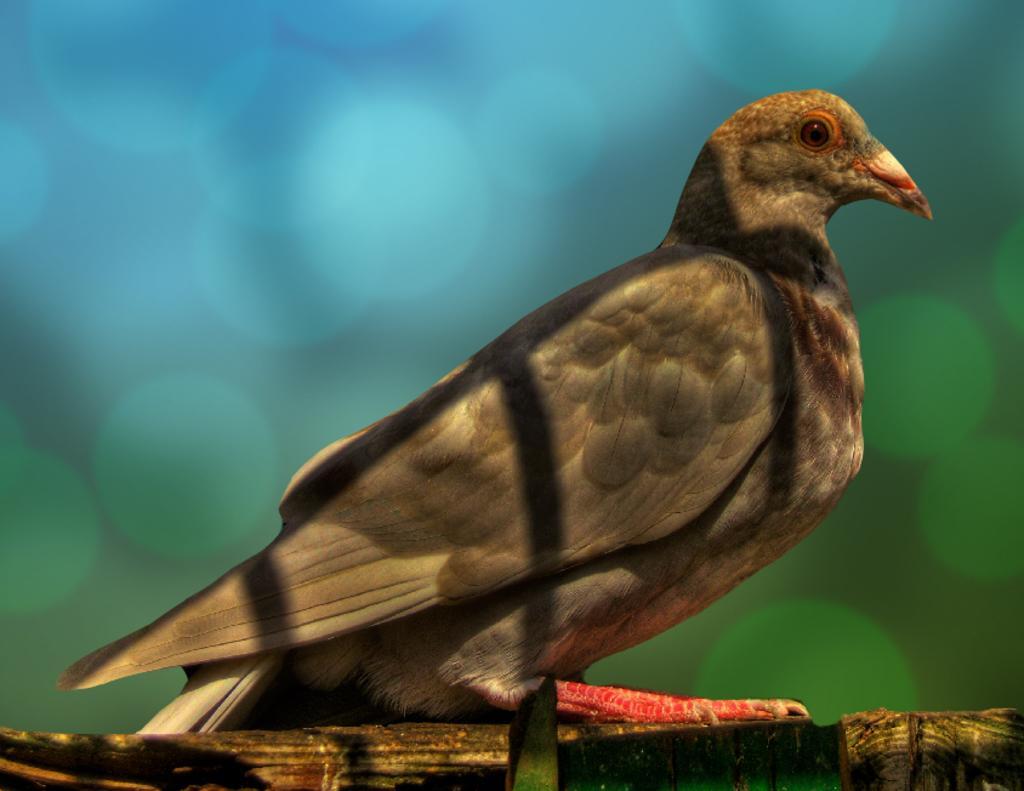In one or two sentences, can you explain what this image depicts? In this image I can see a bird which is brown, black, cream, orange and red in color is on the wooden object and I can see the blurry background which is blue and brown in color. 